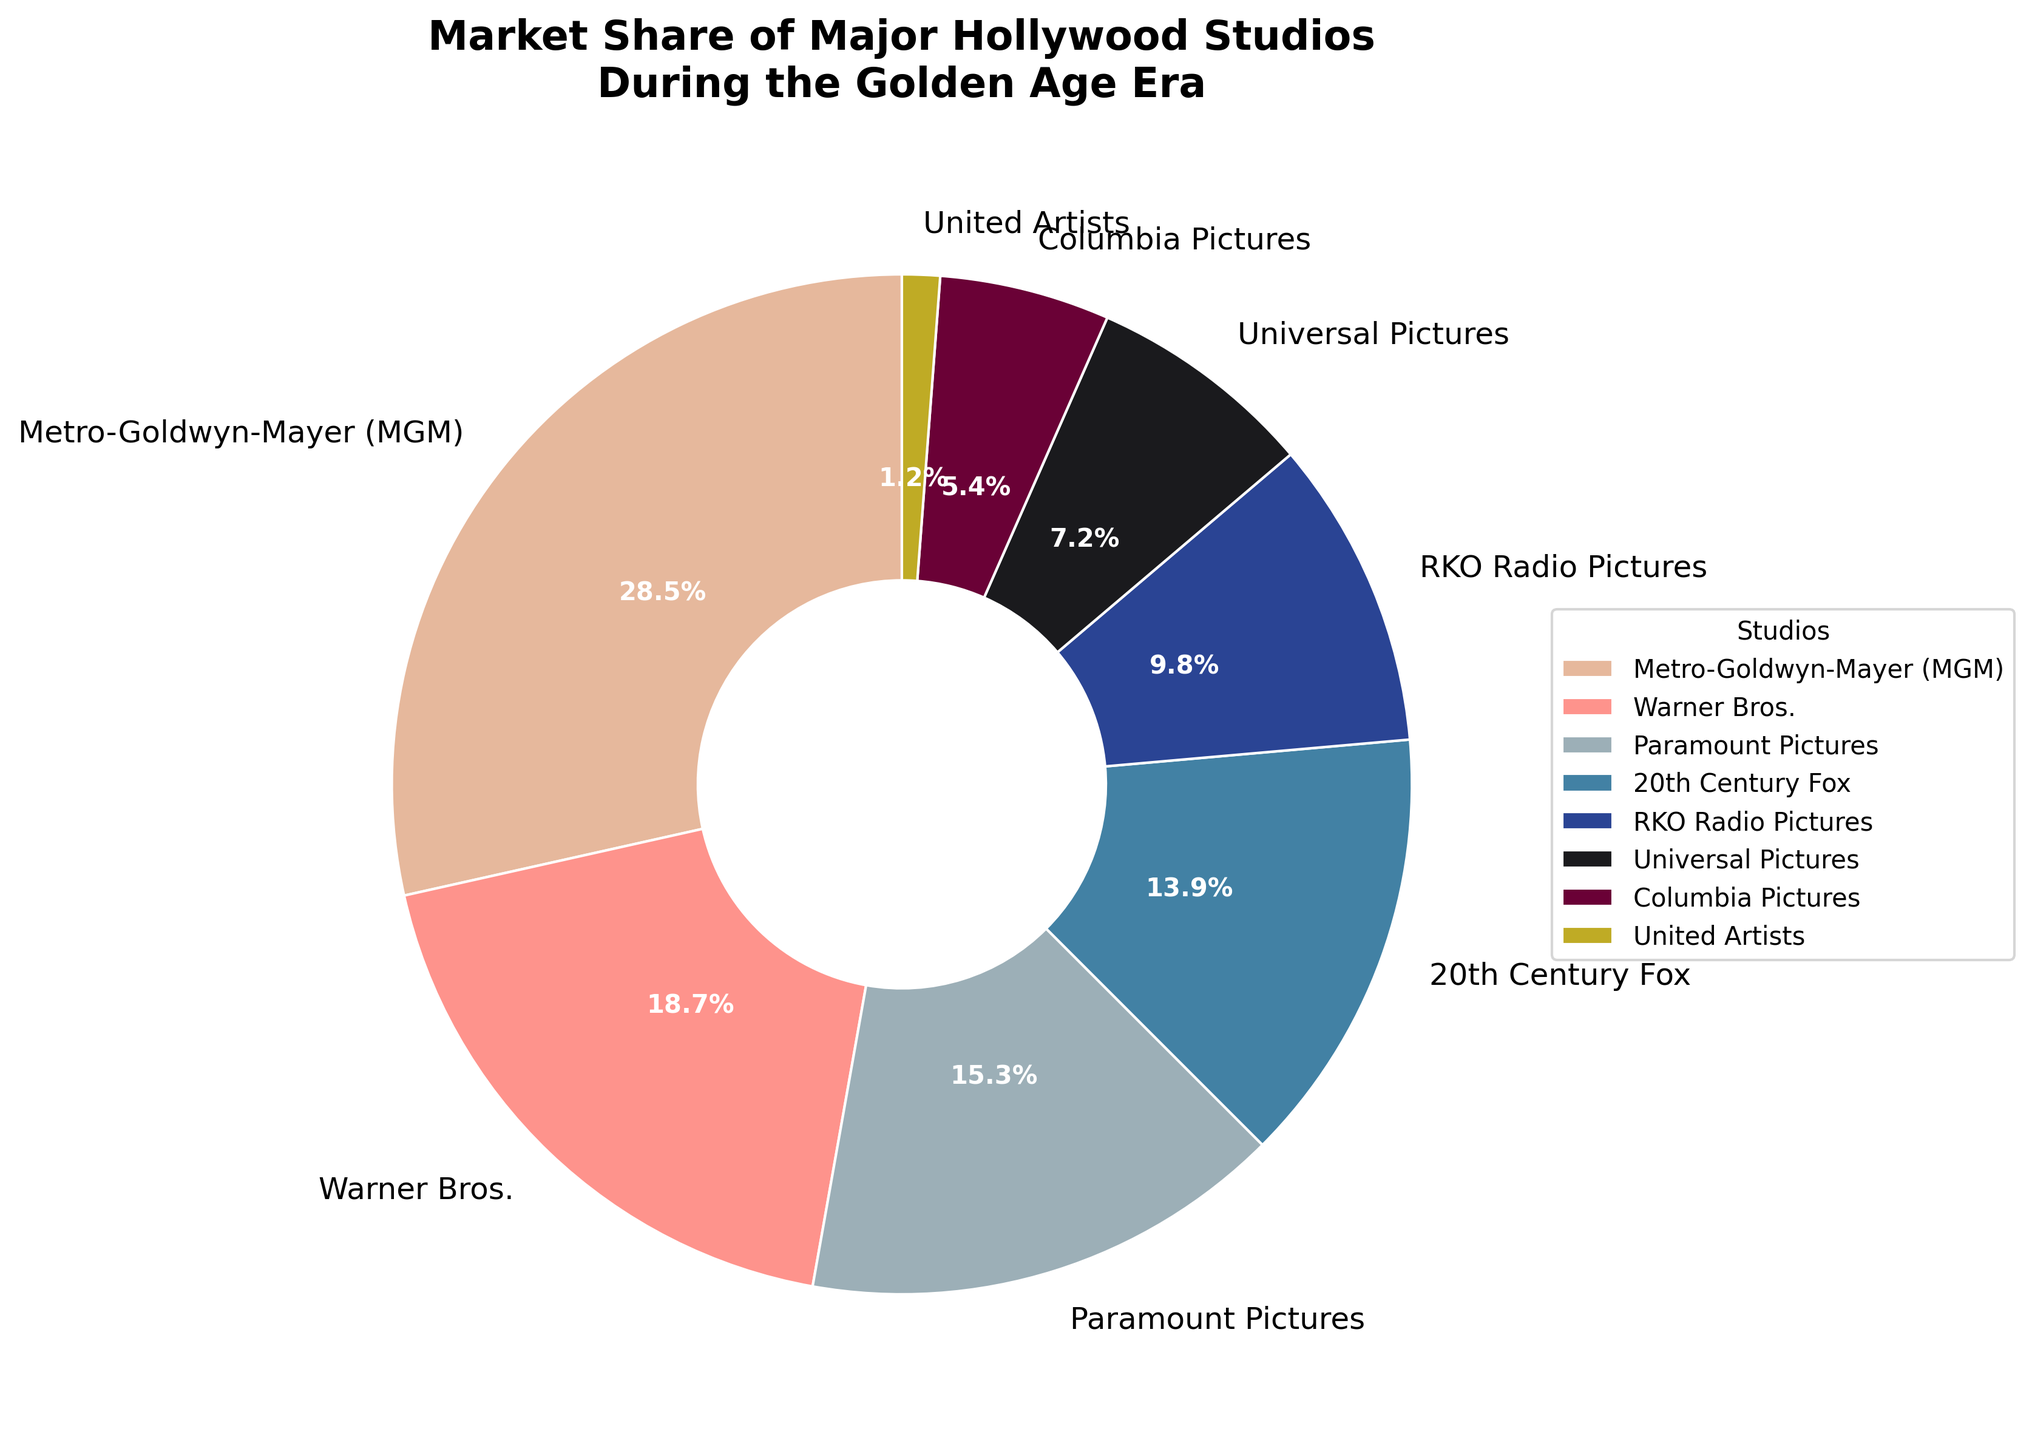What is the combined market share of Warner Bros. and 20th Century Fox? The market share of Warner Bros. is 18.7% and for 20th Century Fox is 13.9%. Adding them together, we get 18.7% + 13.9% = 32.6%.
Answer: 32.6% Which studio had the highest market share? From the pie chart, Metro-Goldwyn-Mayer (MGM) has the largest slice, indicating that it has the highest market share at 28.5%.
Answer: Metro-Goldwyn-Mayer (MGM) How much greater is Metro-Goldwyn-Mayer's market share compared to Paramount Pictures'? The market share of Metro-Goldwyn-Mayer (MGM) is 28.5% and Paramount Pictures is 15.3%. The difference is 28.5% - 15.3% = 13.2%.
Answer: 13.2% Which studios have a market share less than 10%? From the pie chart, RKO Radio Pictures, Universal Pictures, Columbia Pictures, and United Artists have slices smaller than 10%. Their respective market shares are 9.8%, 7.2%, 5.4%, and 1.2%.
Answer: RKO Radio Pictures, Universal Pictures, Columbia Pictures, United Artists Is the market share of RKO Radio Pictures greater than that of Universal Pictures? The market share of RKO Radio Pictures is 9.8%, while Universal Pictures is 7.2%, so RKO Radio Pictures has a greater market share.
Answer: Yes Which studio has the smallest market share and what is it? United Artists has the smallest slice in the pie chart, indicating it has the smallest market share at 1.2%.
Answer: United Artists, 1.2% What is the total market share of the three studios with the highest market shares? The three studios with the highest market shares are Metro-Goldwyn-Mayer (28.5%), Warner Bros. (18.7%), and Paramount Pictures (15.3%). Summing these, we get 28.5% + 18.7% + 15.3% = 62.5%.
Answer: 62.5% Which studio is represented by the dark blue wedge in the pie chart? The dark blue wedge corresponds to 20th Century Fox, which has a market share of 13.9%.
Answer: 20th Century Fox 